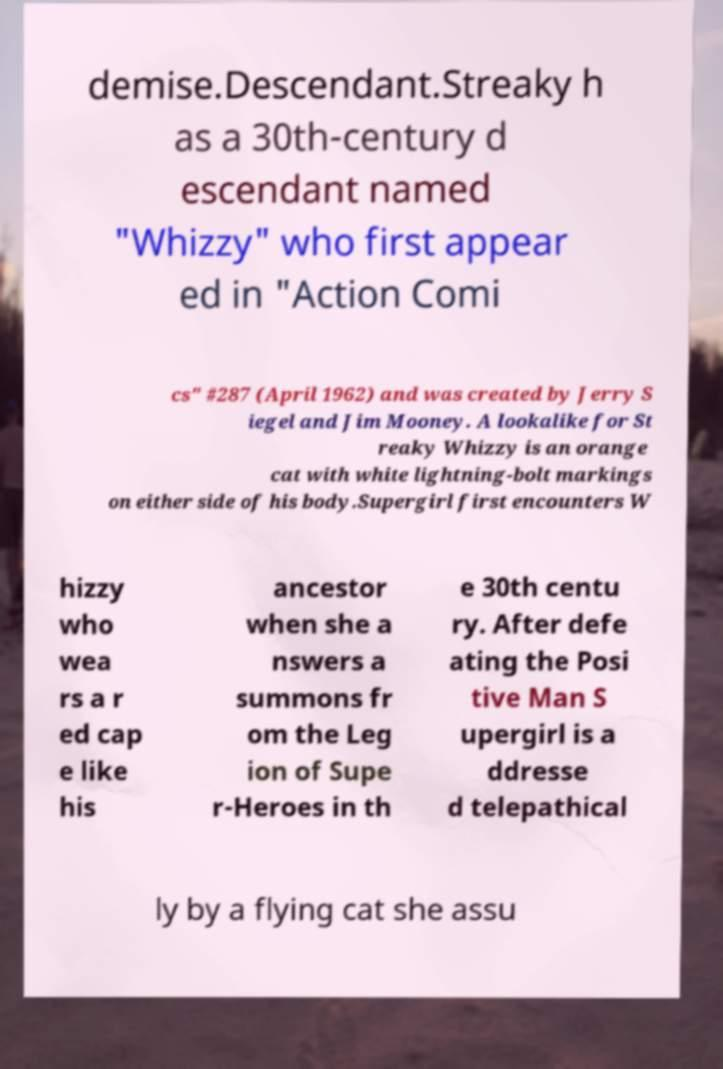There's text embedded in this image that I need extracted. Can you transcribe it verbatim? demise.Descendant.Streaky h as a 30th-century d escendant named "Whizzy" who first appear ed in "Action Comi cs" #287 (April 1962) and was created by Jerry S iegel and Jim Mooney. A lookalike for St reaky Whizzy is an orange cat with white lightning-bolt markings on either side of his body.Supergirl first encounters W hizzy who wea rs a r ed cap e like his ancestor when she a nswers a summons fr om the Leg ion of Supe r-Heroes in th e 30th centu ry. After defe ating the Posi tive Man S upergirl is a ddresse d telepathical ly by a flying cat she assu 